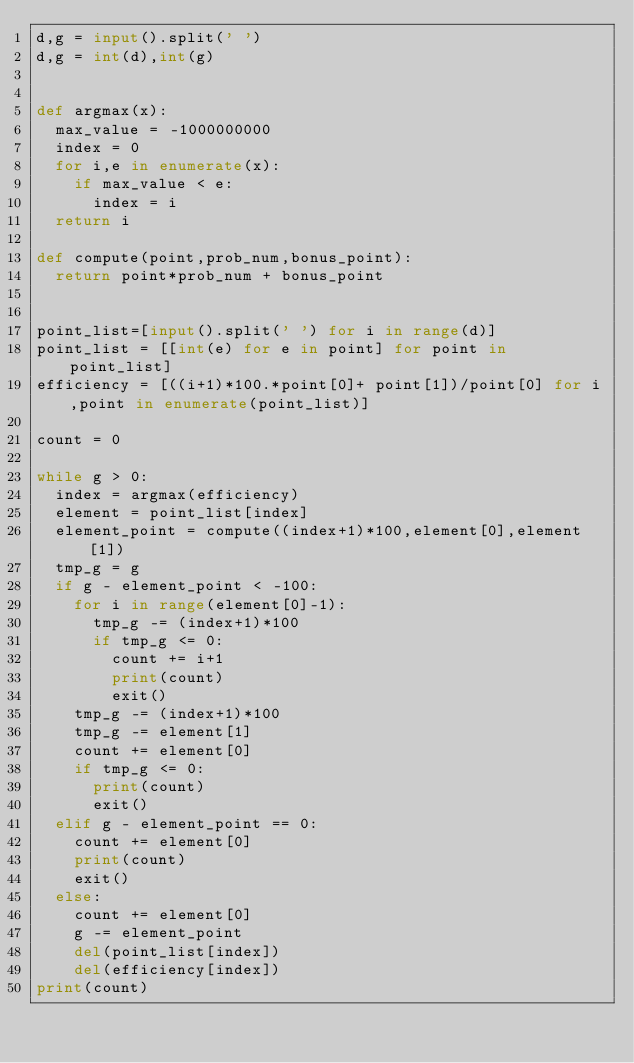<code> <loc_0><loc_0><loc_500><loc_500><_Python_>d,g = input().split(' ')
d,g = int(d),int(g)


def argmax(x):
	max_value = -1000000000
	index = 0
	for i,e in enumerate(x):
		if max_value < e:
			index = i
	return i

def compute(point,prob_num,bonus_point):
	return point*prob_num + bonus_point


point_list=[input().split(' ') for i in range(d)]
point_list = [[int(e) for e in point] for point in point_list]
efficiency = [((i+1)*100.*point[0]+ point[1])/point[0] for i,point in enumerate(point_list)]

count = 0

while g > 0:
	index = argmax(efficiency)
	element = point_list[index]
	element_point = compute((index+1)*100,element[0],element[1])
	tmp_g = g
	if g - element_point < -100:
		for i in range(element[0]-1):
			tmp_g -= (index+1)*100
			if tmp_g <= 0:
				count += i+1
				print(count)
				exit()
		tmp_g -= (index+1)*100
		tmp_g -= element[1]
		count += element[0]
		if tmp_g <= 0:
			print(count)
			exit()
	elif g - element_point == 0:
		count += element[0]
		print(count)
		exit()		
	else:
		count += element[0]
		g -= element_point
		del(point_list[index])
		del(efficiency[index])
print(count)

</code> 